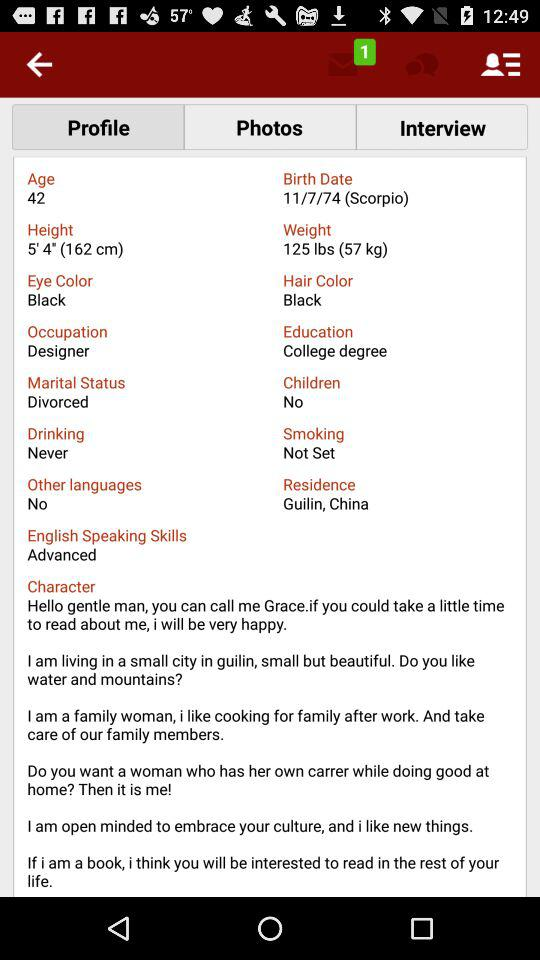What is the height? The height is 5' 4" (162 cm). 